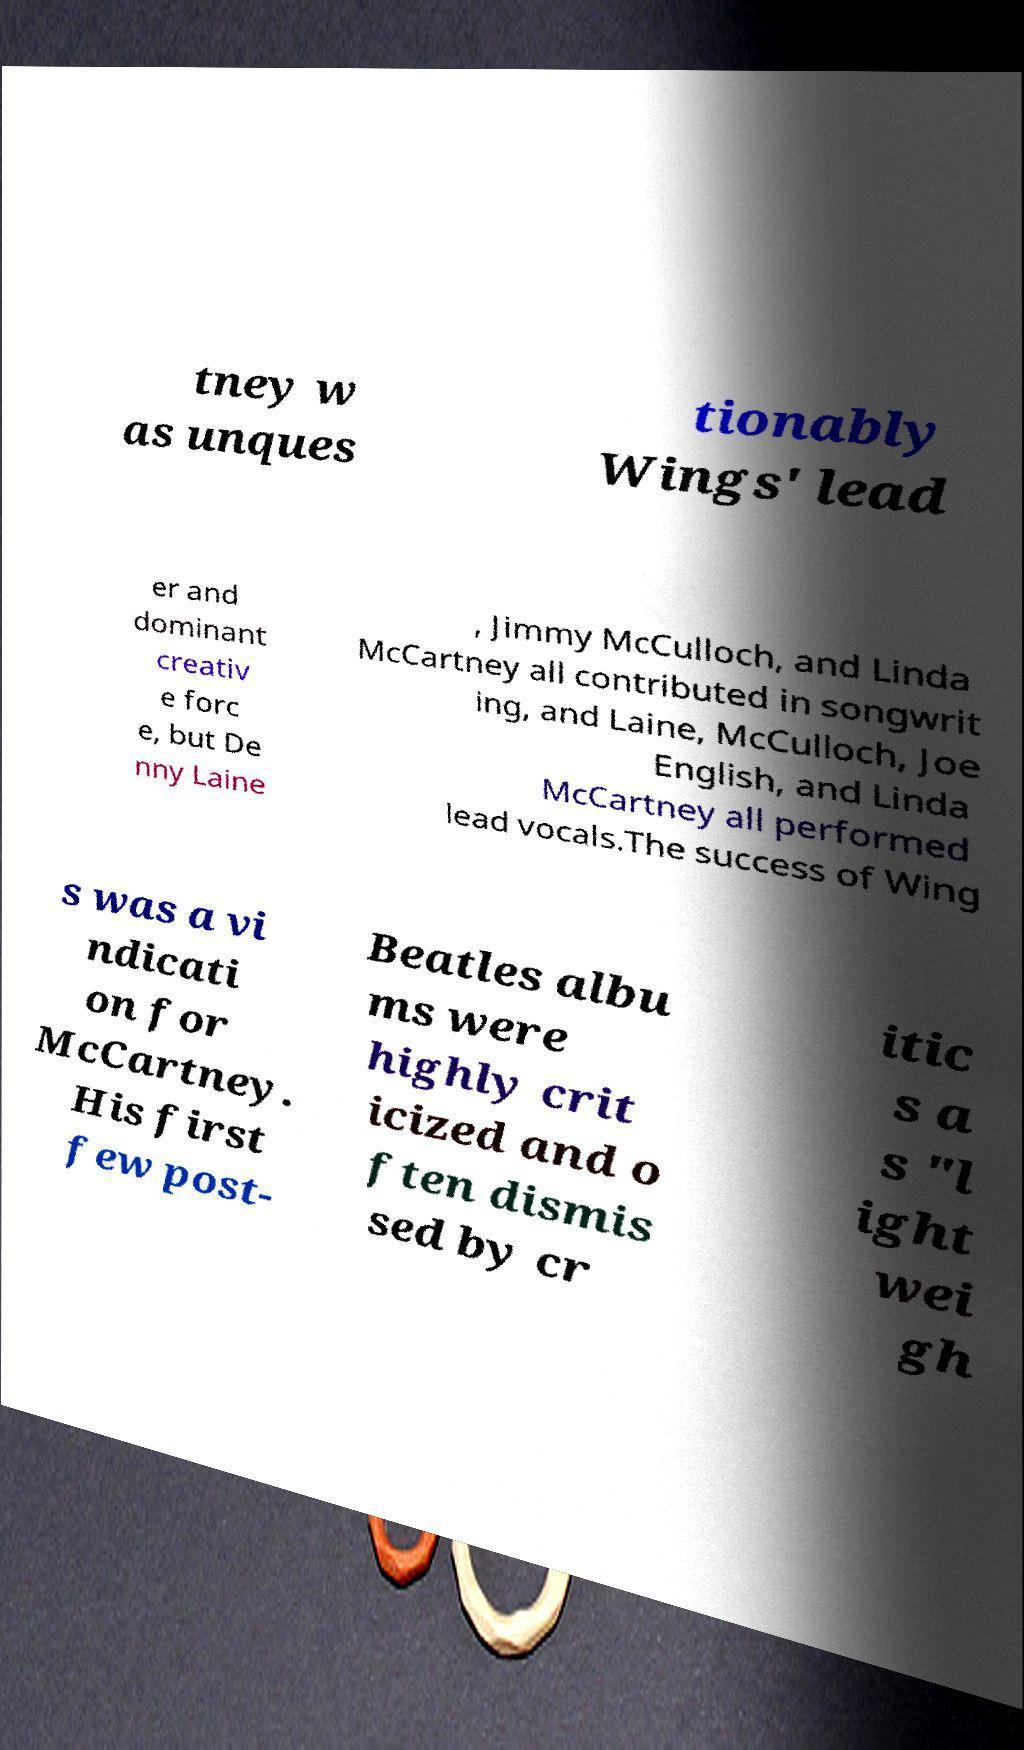Could you extract and type out the text from this image? tney w as unques tionably Wings' lead er and dominant creativ e forc e, but De nny Laine , Jimmy McCulloch, and Linda McCartney all contributed in songwrit ing, and Laine, McCulloch, Joe English, and Linda McCartney all performed lead vocals.The success of Wing s was a vi ndicati on for McCartney. His first few post- Beatles albu ms were highly crit icized and o ften dismis sed by cr itic s a s "l ight wei gh 